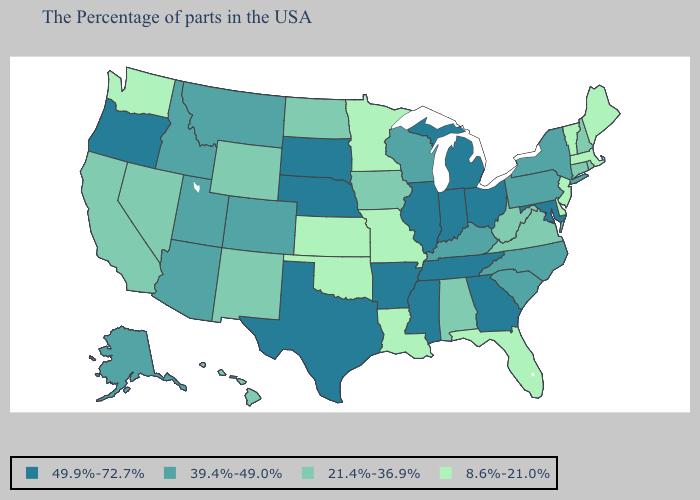Which states have the highest value in the USA?
Quick response, please. Maryland, Ohio, Georgia, Michigan, Indiana, Tennessee, Illinois, Mississippi, Arkansas, Nebraska, Texas, South Dakota, Oregon. Among the states that border Mississippi , which have the highest value?
Concise answer only. Tennessee, Arkansas. Does Kansas have the same value as Alaska?
Give a very brief answer. No. What is the lowest value in the USA?
Answer briefly. 8.6%-21.0%. What is the value of Indiana?
Be succinct. 49.9%-72.7%. Which states have the lowest value in the USA?
Answer briefly. Maine, Massachusetts, Vermont, New Jersey, Delaware, Florida, Louisiana, Missouri, Minnesota, Kansas, Oklahoma, Washington. What is the highest value in the USA?
Give a very brief answer. 49.9%-72.7%. Name the states that have a value in the range 39.4%-49.0%?
Give a very brief answer. New York, Pennsylvania, North Carolina, South Carolina, Kentucky, Wisconsin, Colorado, Utah, Montana, Arizona, Idaho, Alaska. Name the states that have a value in the range 8.6%-21.0%?
Be succinct. Maine, Massachusetts, Vermont, New Jersey, Delaware, Florida, Louisiana, Missouri, Minnesota, Kansas, Oklahoma, Washington. Which states have the highest value in the USA?
Concise answer only. Maryland, Ohio, Georgia, Michigan, Indiana, Tennessee, Illinois, Mississippi, Arkansas, Nebraska, Texas, South Dakota, Oregon. Name the states that have a value in the range 21.4%-36.9%?
Write a very short answer. Rhode Island, New Hampshire, Connecticut, Virginia, West Virginia, Alabama, Iowa, North Dakota, Wyoming, New Mexico, Nevada, California, Hawaii. Does the first symbol in the legend represent the smallest category?
Keep it brief. No. Which states hav the highest value in the West?
Write a very short answer. Oregon. What is the value of Colorado?
Give a very brief answer. 39.4%-49.0%. Does Kansas have the lowest value in the MidWest?
Be succinct. Yes. 